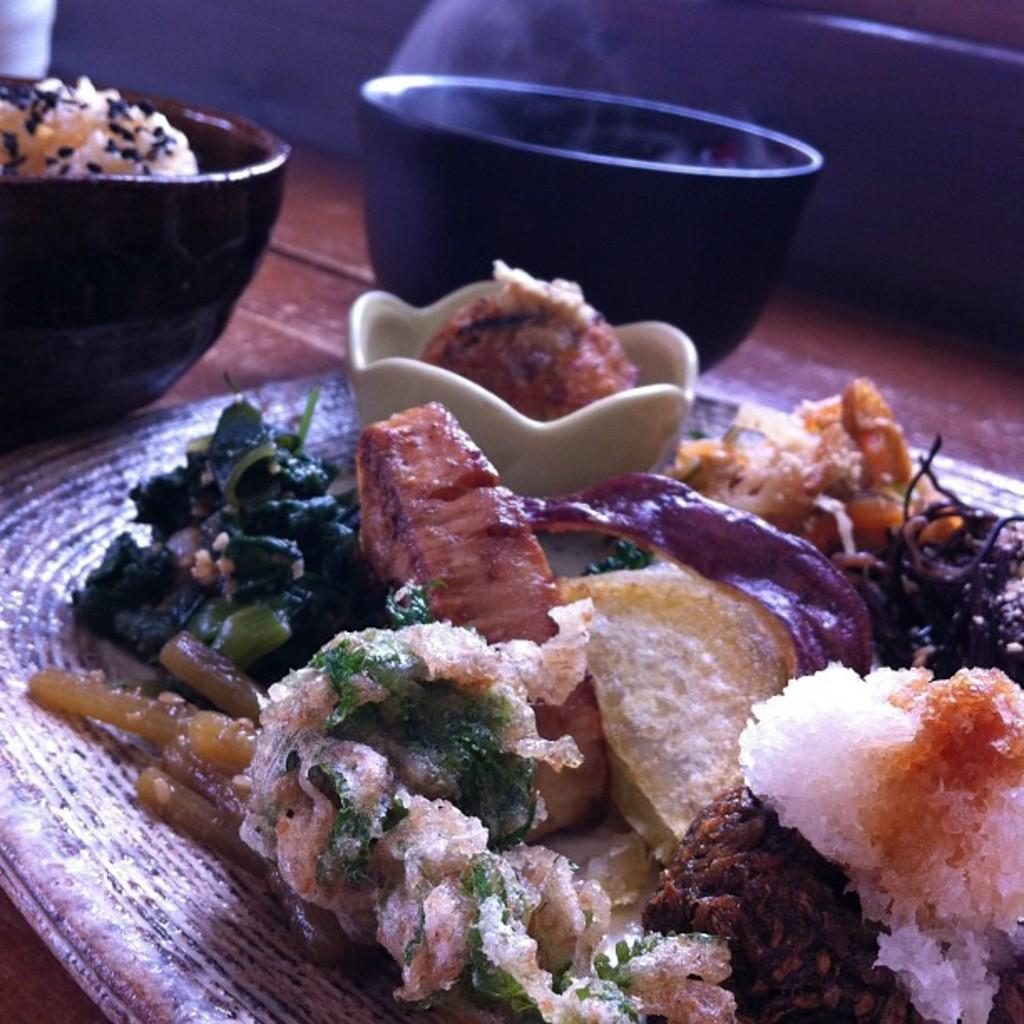What piece of furniture is present in the image? There is a table in the image. What is placed on the table? There is a plate on the table. What is on the plate? There are food items in the plate. What type of containers are also on the table? There are two black color bowls on the table. Can you tell me where the map is located in the image? There is no map present in the image. What type of animal is sitting next to the table in the image? There is no animal, such as a donkey, present in the image. 